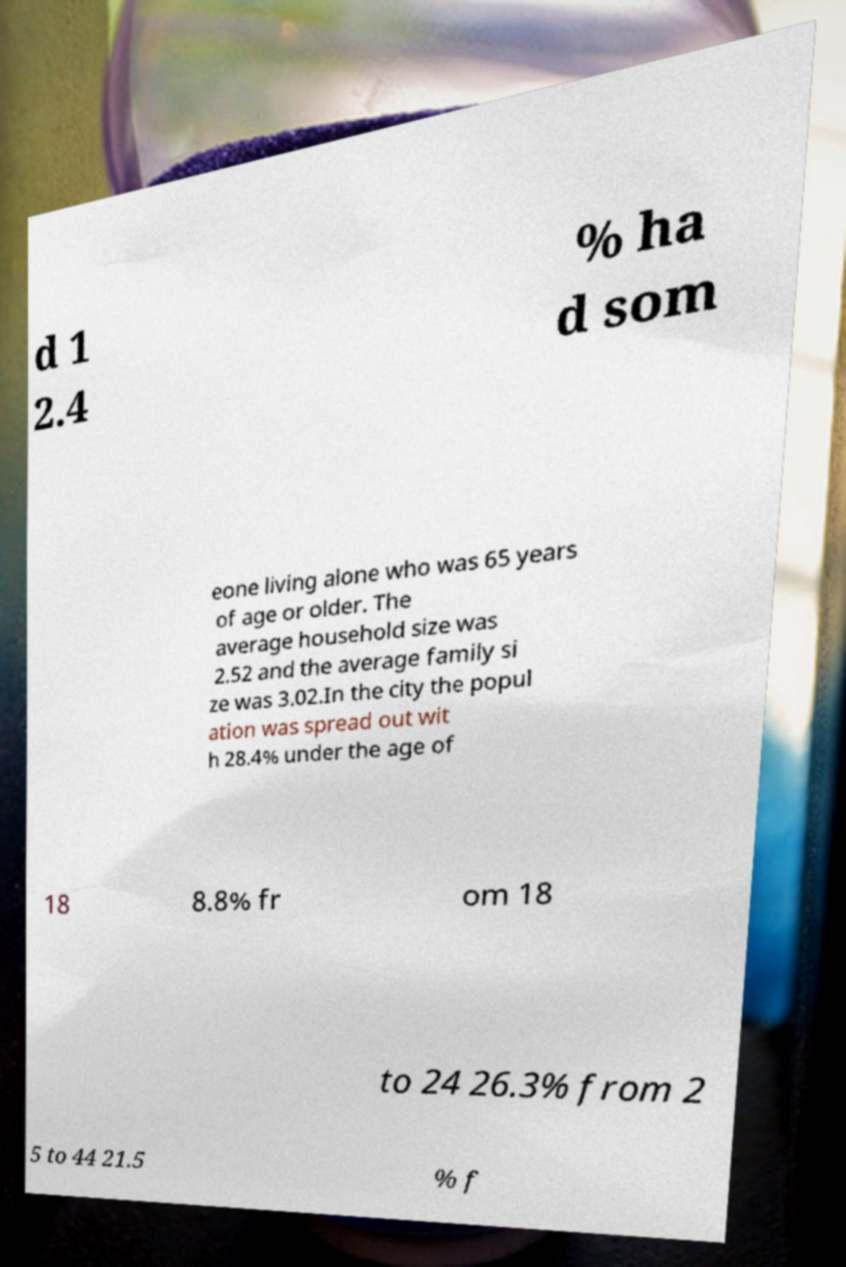Please identify and transcribe the text found in this image. d 1 2.4 % ha d som eone living alone who was 65 years of age or older. The average household size was 2.52 and the average family si ze was 3.02.In the city the popul ation was spread out wit h 28.4% under the age of 18 8.8% fr om 18 to 24 26.3% from 2 5 to 44 21.5 % f 